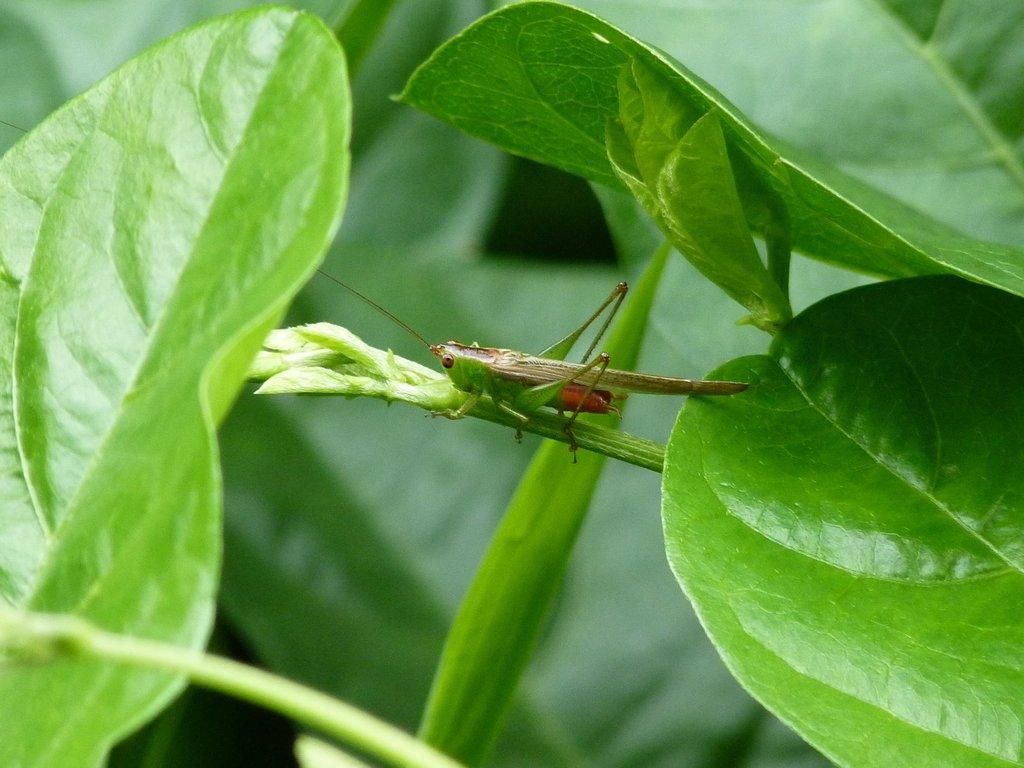What is present in the picture? There is a plant in the picture. Is there anything on the plant? Yes, a grasshopper is on the plant. What color are the leaves of the plant? The leaves in the picture are green. What type of decision can be seen being made by the coast in the image? There is no coast present in the image, and therefore no decision can be seen being made by it. 